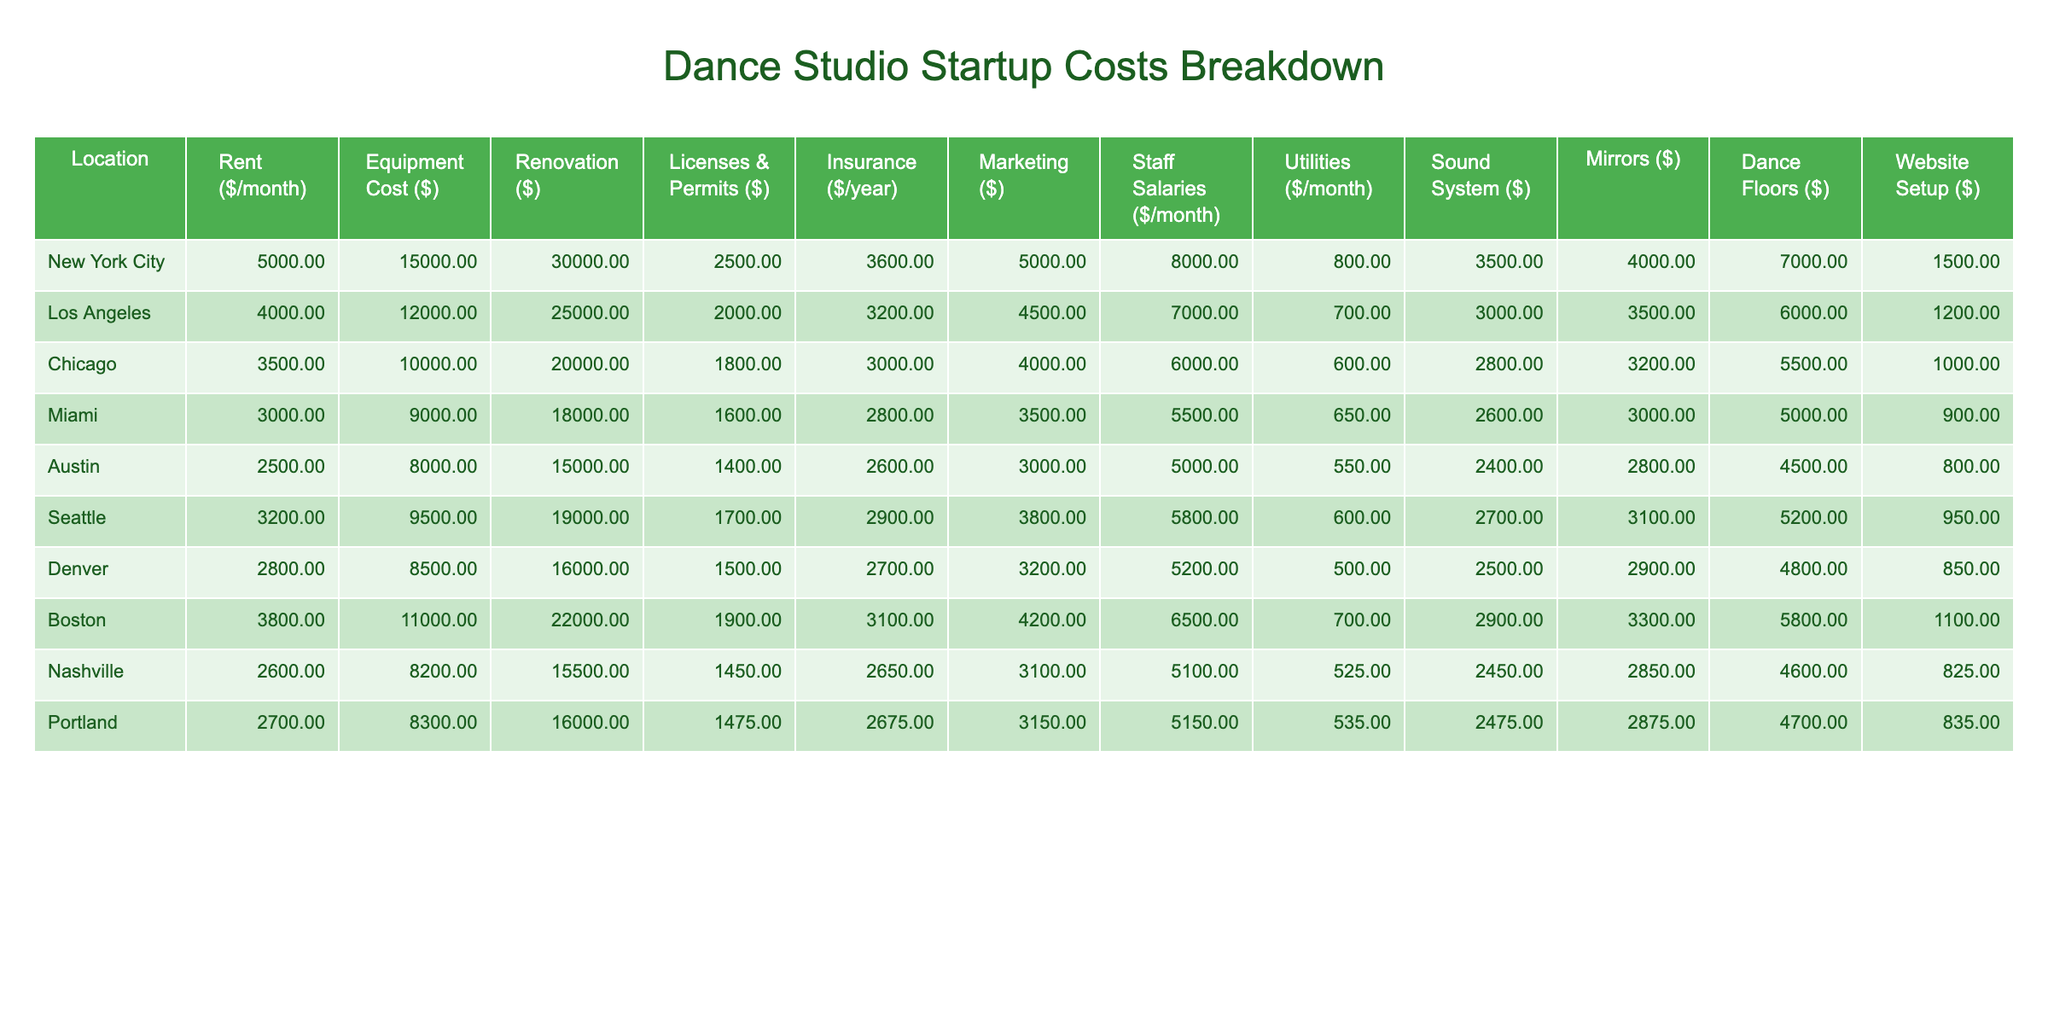What is the rent for a dance studio in Los Angeles? The table shows that the rent for a dance studio in Los Angeles is listed as $4,000 per month.
Answer: $4,000 Which location has the highest equipment cost? By examining the table, we see that New York City has the highest equipment cost at $15,000.
Answer: New York City What is the average utility cost across all locations? To find the average utility cost, we first sum all the utility costs: (800 + 700 + 600 + 650 + 550 + 500 + 700 + 525 + 535) = 5,605. Then we divide by the number of locations (9): 5,605 / 9 ≈ 622.78.
Answer: Approximately $622.78 Is it true that rent is higher in Chicago than in Miami? The table indicates that rent in Chicago is $3,500 while in Miami it is $3,000. Since $3,500 is greater than $3,000, the statement is true.
Answer: Yes What is the total cost of starting a dance studio in Portland, including all costs listed? For Portland, we sum all the costs: Rent ($2,700) + Equipment Cost ($8,300) + Renovation ($16,000) + Licenses & Permits ($1,475) + Insurance ($2,675) + Marketing ($3,150) + Staff Salaries ($5,150) + Utilities ($535) + Sound System ($2,475) + Mirrors ($2,875) + Dance Floors ($4,700) + Website Setup ($835) = $56,675.
Answer: $56,675 Which city has the lowest total startup cost based on the table? We will calculate the total startup cost for each city and compare them. The lowest total is found to be Austin, with a total of $38,000.
Answer: Austin How does the insurance cost in Boston compare to that in Seattle? The insurance cost in Boston is $3,100 per year, while in Seattle it is $2,900. Since $3,100 is greater than $2,900, Boston has a higher insurance cost.
Answer: Boston has a higher insurance cost What is the difference in staff salaries between New York City and Nashville? The staff salaries are $8,000 in New York City and $5,100 in Nashville. To find the difference: $8,000 - $5,100 = $2,900.
Answer: $2,900 What is the total cost for licenses and permits in all the locations combined? We sum the licenses and permits costs for all locations: ($2,500 + $2,000 + $1,800 + $1,600 + $1,400 + $1,700 + $1,900 + $1,450 + $1,475) = $15,825.
Answer: $15,825 Which location has the highest marketing cost? Reviewing the marketing costs, New York City has the highest cost at $5,000.
Answer: New York City 